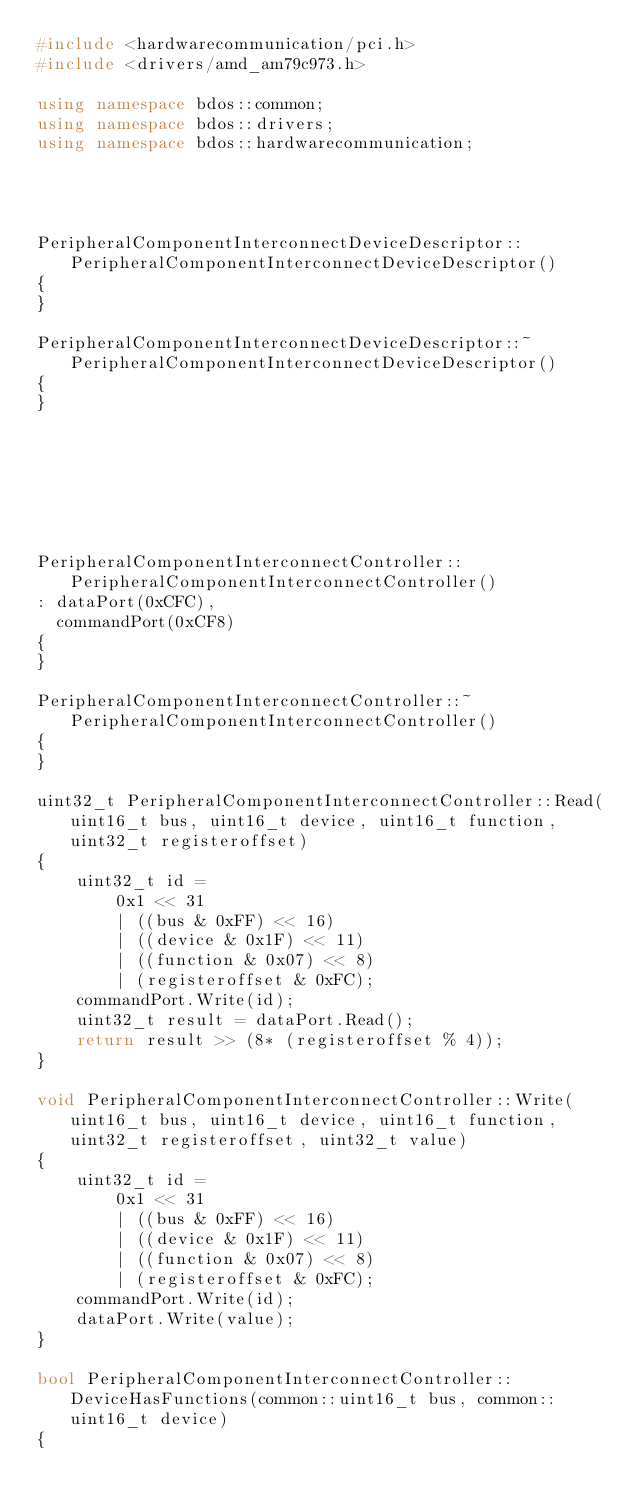<code> <loc_0><loc_0><loc_500><loc_500><_C++_>#include <hardwarecommunication/pci.h>
#include <drivers/amd_am79c973.h>

using namespace bdos::common;
using namespace bdos::drivers;
using namespace bdos::hardwarecommunication;




PeripheralComponentInterconnectDeviceDescriptor::PeripheralComponentInterconnectDeviceDescriptor()
{
}

PeripheralComponentInterconnectDeviceDescriptor::~PeripheralComponentInterconnectDeviceDescriptor()
{
}







PeripheralComponentInterconnectController::PeripheralComponentInterconnectController()
: dataPort(0xCFC),
  commandPort(0xCF8)
{
}

PeripheralComponentInterconnectController::~PeripheralComponentInterconnectController()
{
}

uint32_t PeripheralComponentInterconnectController::Read(uint16_t bus, uint16_t device, uint16_t function, uint32_t registeroffset)
{
    uint32_t id =
        0x1 << 31
        | ((bus & 0xFF) << 16)
        | ((device & 0x1F) << 11)
        | ((function & 0x07) << 8)
        | (registeroffset & 0xFC);
    commandPort.Write(id);
    uint32_t result = dataPort.Read();
    return result >> (8* (registeroffset % 4));
}

void PeripheralComponentInterconnectController::Write(uint16_t bus, uint16_t device, uint16_t function, uint32_t registeroffset, uint32_t value)
{
    uint32_t id =
        0x1 << 31
        | ((bus & 0xFF) << 16)
        | ((device & 0x1F) << 11)
        | ((function & 0x07) << 8)
        | (registeroffset & 0xFC);
    commandPort.Write(id);
    dataPort.Write(value); 
}

bool PeripheralComponentInterconnectController::DeviceHasFunctions(common::uint16_t bus, common::uint16_t device)
{</code> 